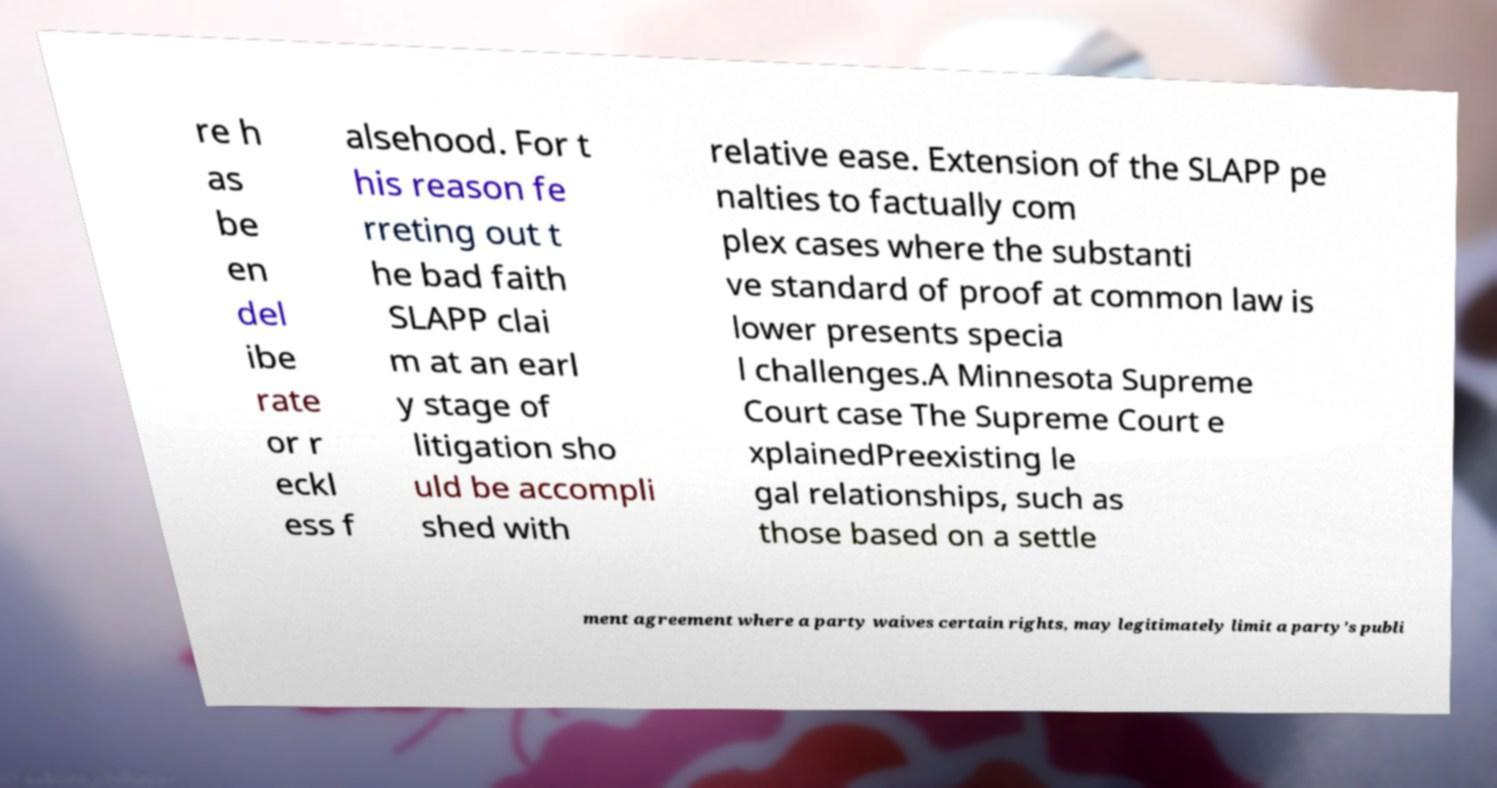Could you assist in decoding the text presented in this image and type it out clearly? re h as be en del ibe rate or r eckl ess f alsehood. For t his reason fe rreting out t he bad faith SLAPP clai m at an earl y stage of litigation sho uld be accompli shed with relative ease. Extension of the SLAPP pe nalties to factually com plex cases where the substanti ve standard of proof at common law is lower presents specia l challenges.A Minnesota Supreme Court case The Supreme Court e xplainedPreexisting le gal relationships, such as those based on a settle ment agreement where a party waives certain rights, may legitimately limit a party's publi 